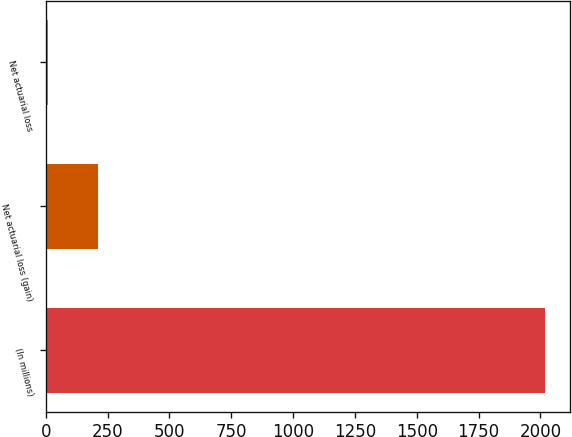Convert chart to OTSL. <chart><loc_0><loc_0><loc_500><loc_500><bar_chart><fcel>(In millions)<fcel>Net actuarial loss (gain)<fcel>Net actuarial loss<nl><fcel>2017<fcel>211.6<fcel>11<nl></chart> 